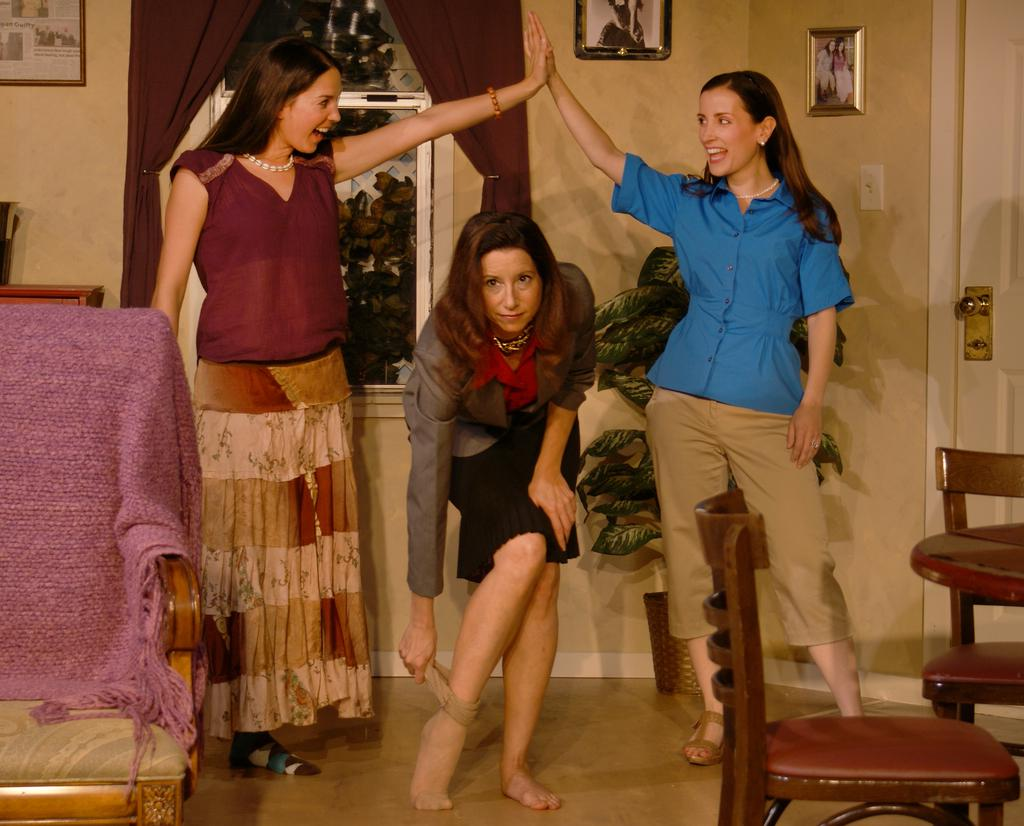How many girls are in the image? There are three girls in the image. What are the girls wearing? The girls are wearing skirts, pants, and shirts. Where does the image take place? The image takes place in a house. What furniture can be seen in the house? There is a chair in the house. What type of decoration is present in the house? There is a plant and photos hanging on the wall in the house. What is the income of the girls in the image? There is no information about the girls' income in the image. Are the girls planning a trip in the image? There is no indication of a trip or any travel plans in the image. 